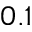Convert formula to latex. <formula><loc_0><loc_0><loc_500><loc_500>0 . 1</formula> 